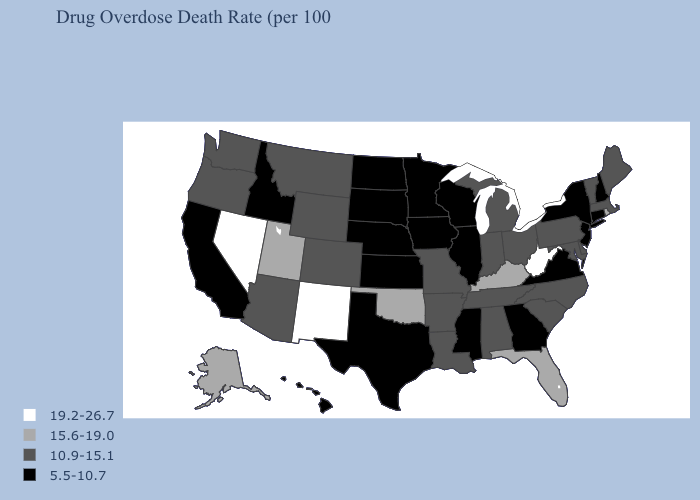Name the states that have a value in the range 19.2-26.7?
Write a very short answer. Nevada, New Mexico, West Virginia. What is the highest value in states that border Colorado?
Short answer required. 19.2-26.7. Does Tennessee have a higher value than California?
Quick response, please. Yes. Among the states that border West Virginia , which have the highest value?
Answer briefly. Kentucky. What is the value of Minnesota?
Give a very brief answer. 5.5-10.7. What is the highest value in the West ?
Quick response, please. 19.2-26.7. Name the states that have a value in the range 10.9-15.1?
Give a very brief answer. Alabama, Arizona, Arkansas, Colorado, Delaware, Indiana, Louisiana, Maine, Maryland, Massachusetts, Michigan, Missouri, Montana, North Carolina, Ohio, Oregon, Pennsylvania, South Carolina, Tennessee, Vermont, Washington, Wyoming. Does Kentucky have the lowest value in the USA?
Keep it brief. No. Does the map have missing data?
Give a very brief answer. No. What is the value of Alabama?
Quick response, please. 10.9-15.1. What is the value of Delaware?
Keep it brief. 10.9-15.1. Does Georgia have a lower value than Missouri?
Give a very brief answer. Yes. Which states have the lowest value in the West?
Write a very short answer. California, Hawaii, Idaho. Is the legend a continuous bar?
Answer briefly. No. Name the states that have a value in the range 15.6-19.0?
Concise answer only. Alaska, Florida, Kentucky, Oklahoma, Rhode Island, Utah. 